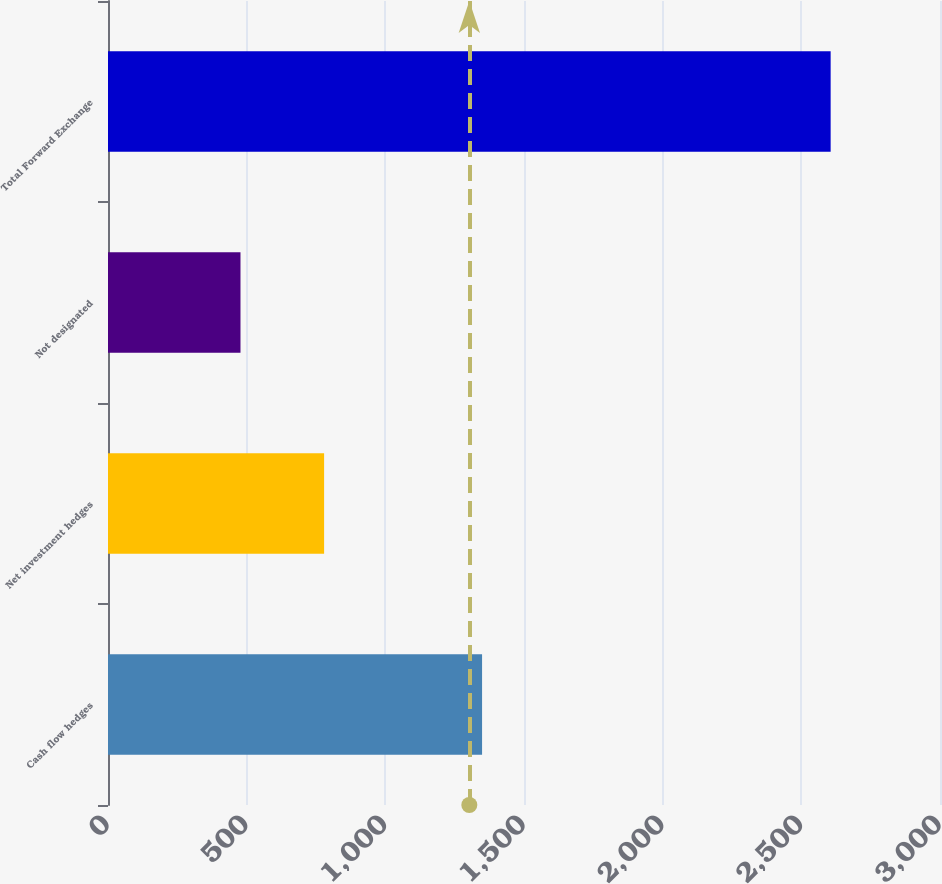Convert chart. <chart><loc_0><loc_0><loc_500><loc_500><bar_chart><fcel>Cash flow hedges<fcel>Net investment hedges<fcel>Not designated<fcel>Total Forward Exchange<nl><fcel>1348.8<fcel>779.2<fcel>477.7<fcel>2605.7<nl></chart> 